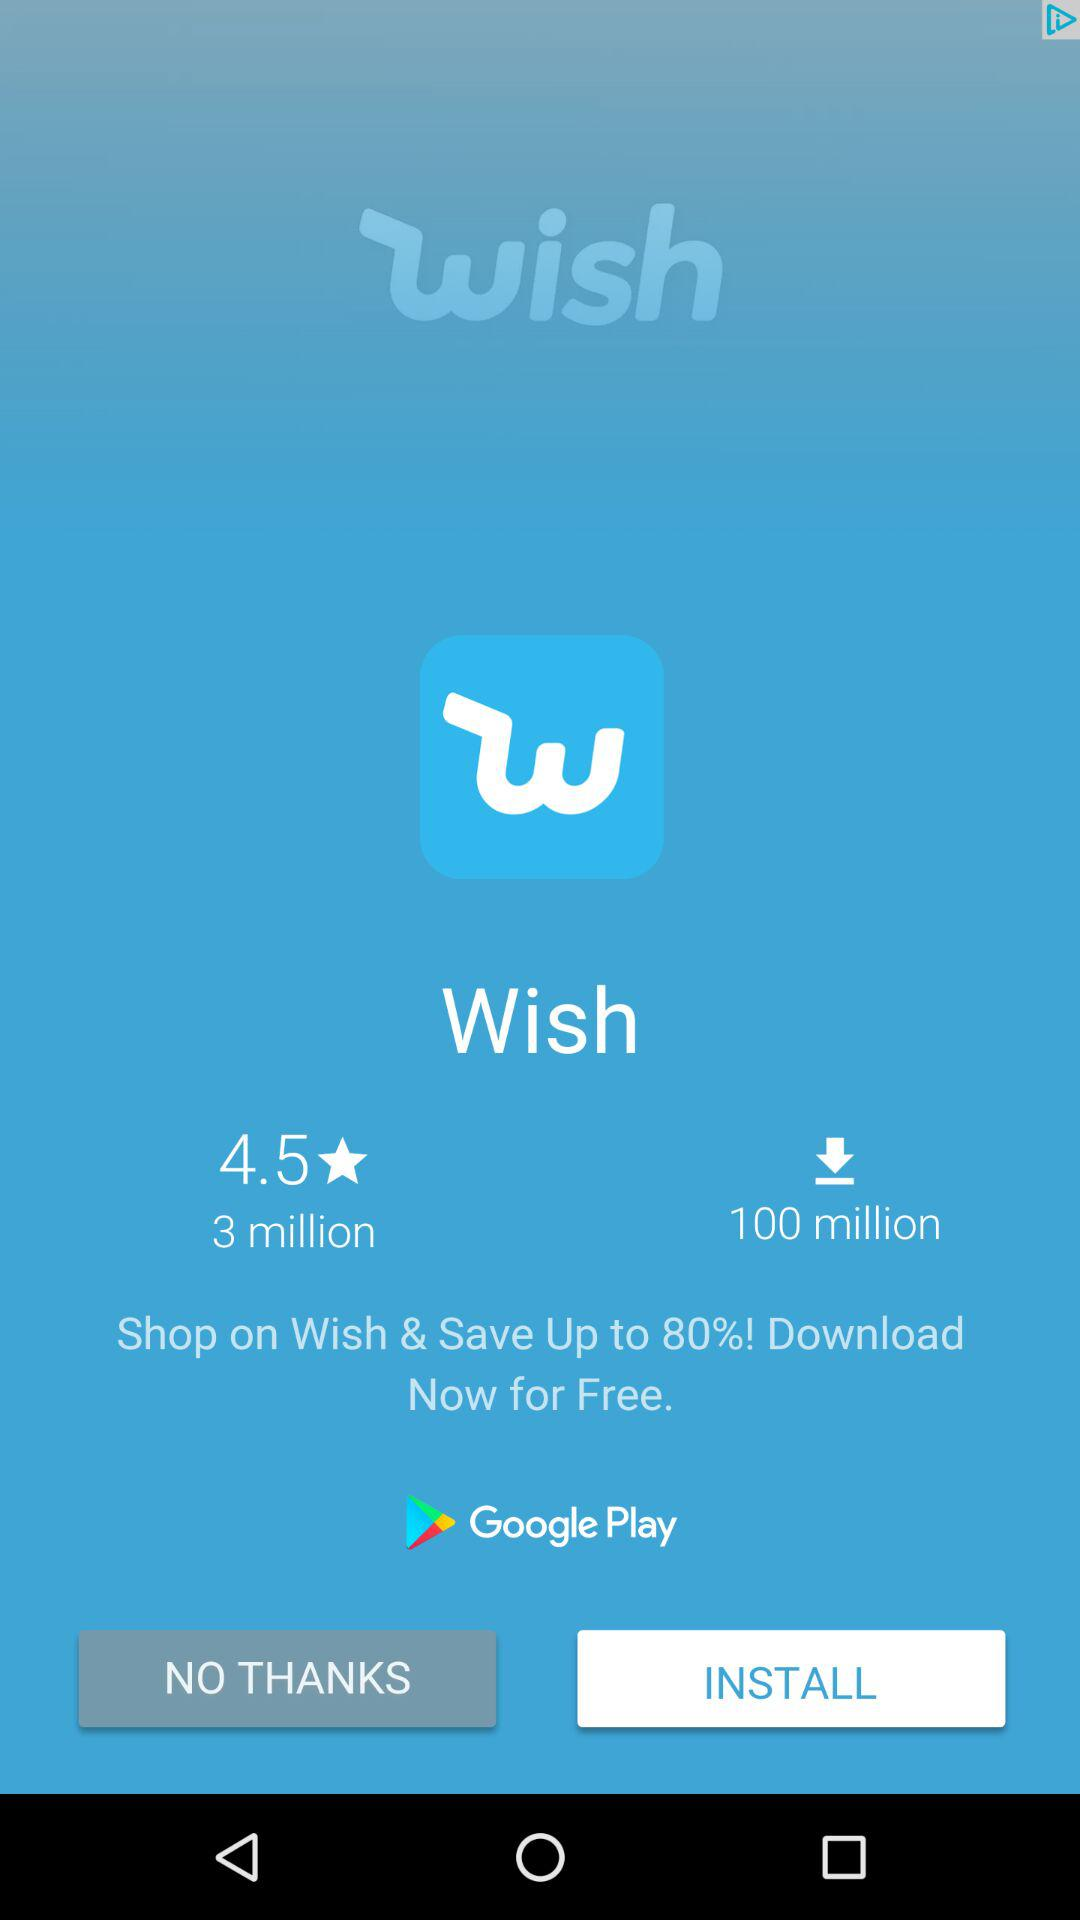How many more downloads does Wish have than reviews?
Answer the question using a single word or phrase. 97 million 